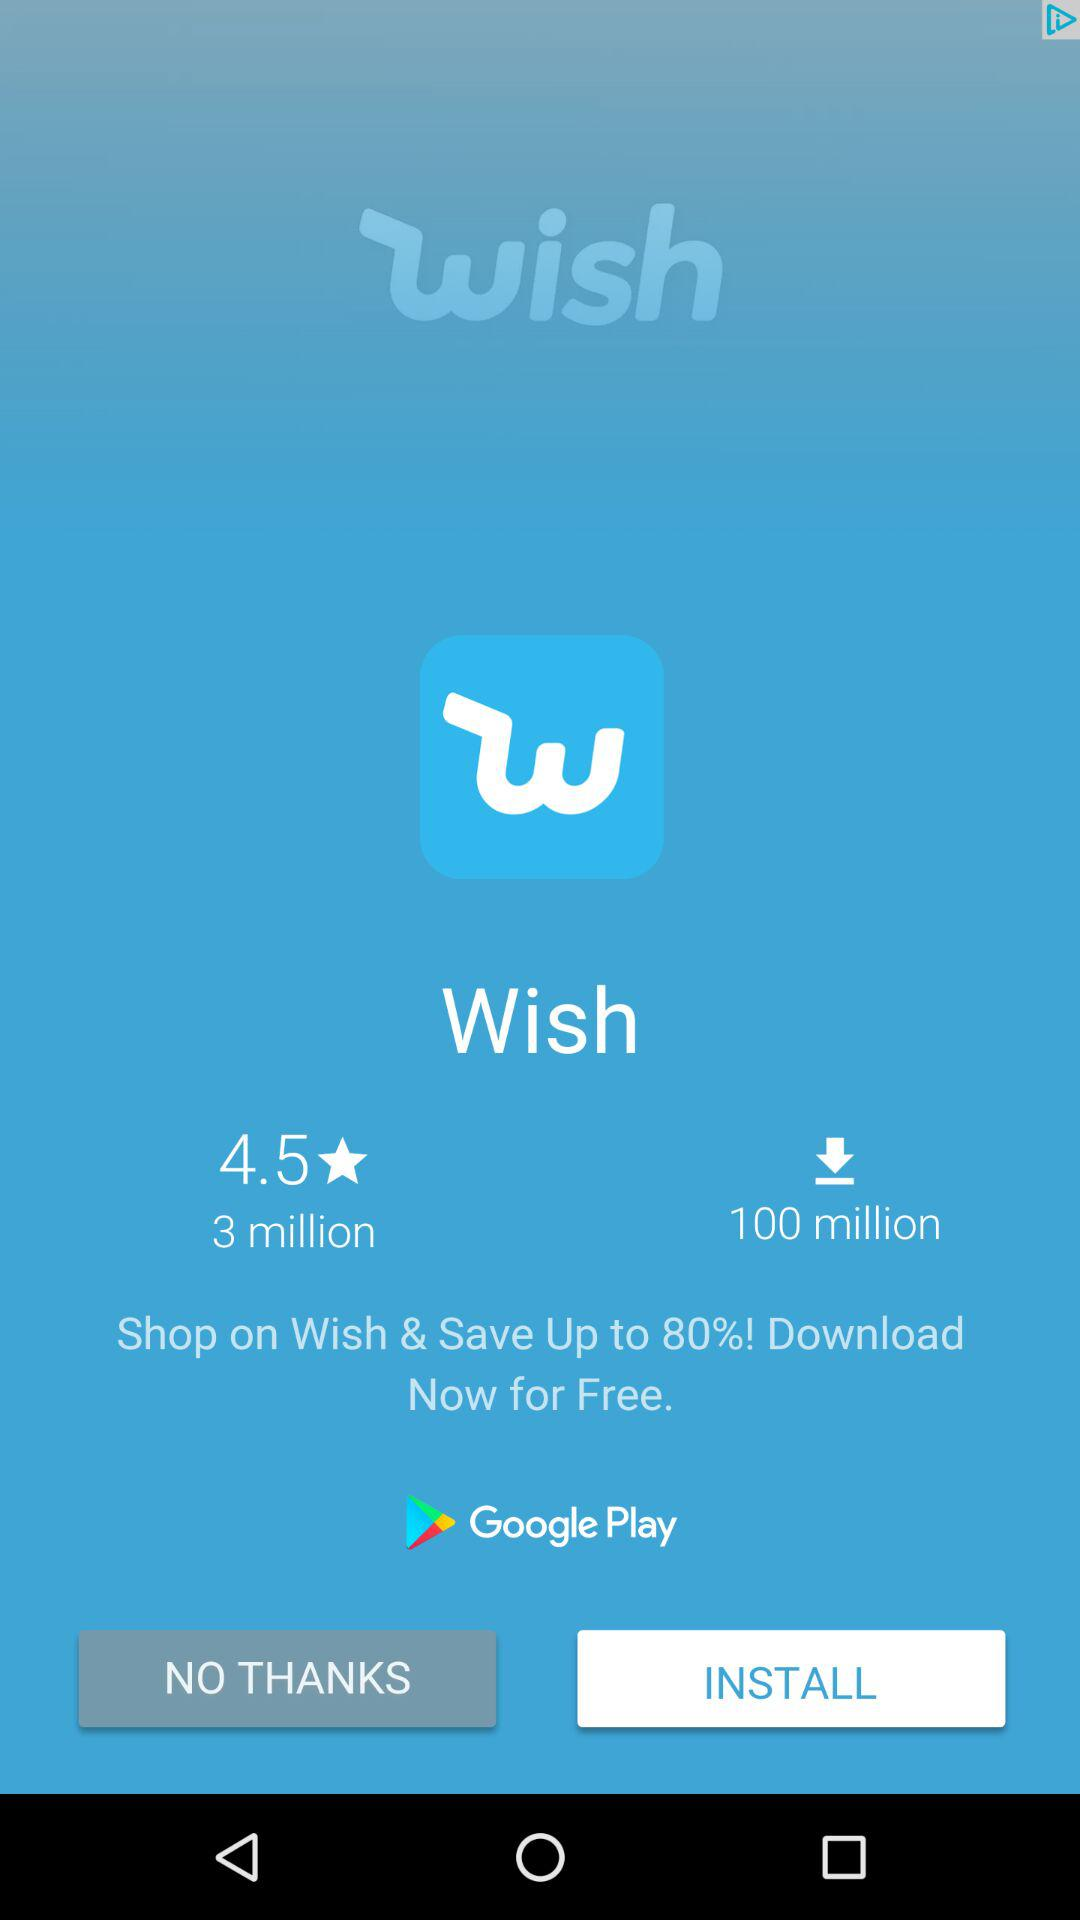How many more downloads does Wish have than reviews?
Answer the question using a single word or phrase. 97 million 